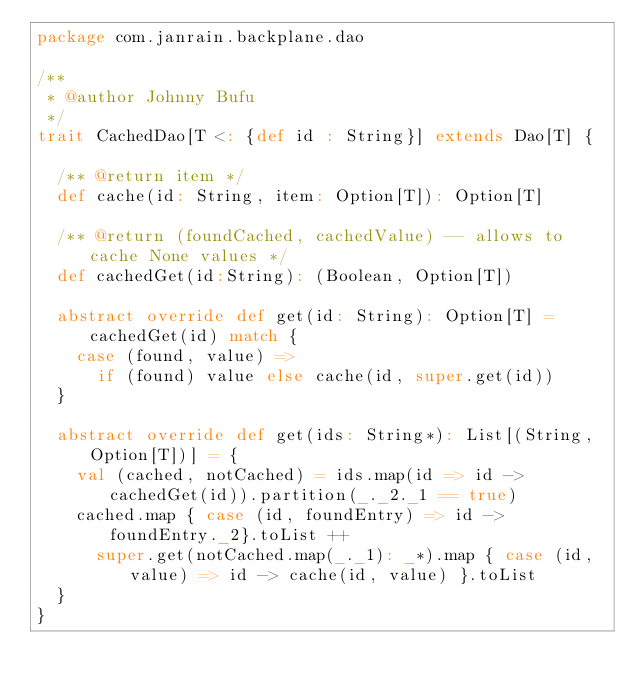Convert code to text. <code><loc_0><loc_0><loc_500><loc_500><_Scala_>package com.janrain.backplane.dao

/**
 * @author Johnny Bufu
 */
trait CachedDao[T <: {def id : String}] extends Dao[T] {

  /** @return item */
  def cache(id: String, item: Option[T]): Option[T]

  /** @return (foundCached, cachedValue) -- allows to cache None values */
  def cachedGet(id:String): (Boolean, Option[T])

  abstract override def get(id: String): Option[T] = cachedGet(id) match {
    case (found, value) =>
      if (found) value else cache(id, super.get(id))
  }

  abstract override def get(ids: String*): List[(String,Option[T])] = {
    val (cached, notCached) = ids.map(id => id -> cachedGet(id)).partition(_._2._1 == true)
    cached.map { case (id, foundEntry) => id -> foundEntry._2}.toList ++
      super.get(notCached.map(_._1): _*).map { case (id, value) => id -> cache(id, value) }.toList
  }
}
</code> 